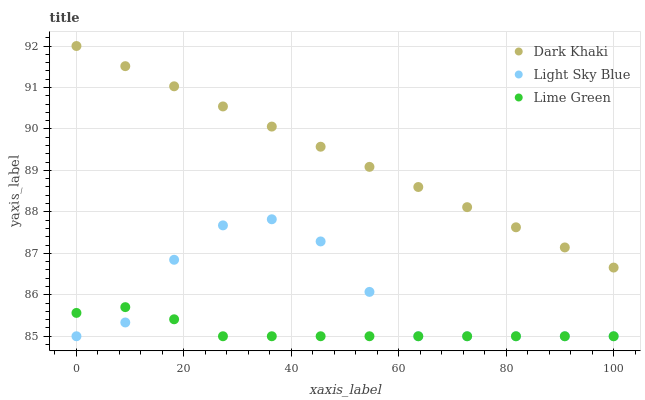Does Lime Green have the minimum area under the curve?
Answer yes or no. Yes. Does Dark Khaki have the maximum area under the curve?
Answer yes or no. Yes. Does Light Sky Blue have the minimum area under the curve?
Answer yes or no. No. Does Light Sky Blue have the maximum area under the curve?
Answer yes or no. No. Is Dark Khaki the smoothest?
Answer yes or no. Yes. Is Light Sky Blue the roughest?
Answer yes or no. Yes. Is Lime Green the smoothest?
Answer yes or no. No. Is Lime Green the roughest?
Answer yes or no. No. Does Light Sky Blue have the lowest value?
Answer yes or no. Yes. Does Dark Khaki have the highest value?
Answer yes or no. Yes. Does Light Sky Blue have the highest value?
Answer yes or no. No. Is Light Sky Blue less than Dark Khaki?
Answer yes or no. Yes. Is Dark Khaki greater than Light Sky Blue?
Answer yes or no. Yes. Does Light Sky Blue intersect Lime Green?
Answer yes or no. Yes. Is Light Sky Blue less than Lime Green?
Answer yes or no. No. Is Light Sky Blue greater than Lime Green?
Answer yes or no. No. Does Light Sky Blue intersect Dark Khaki?
Answer yes or no. No. 